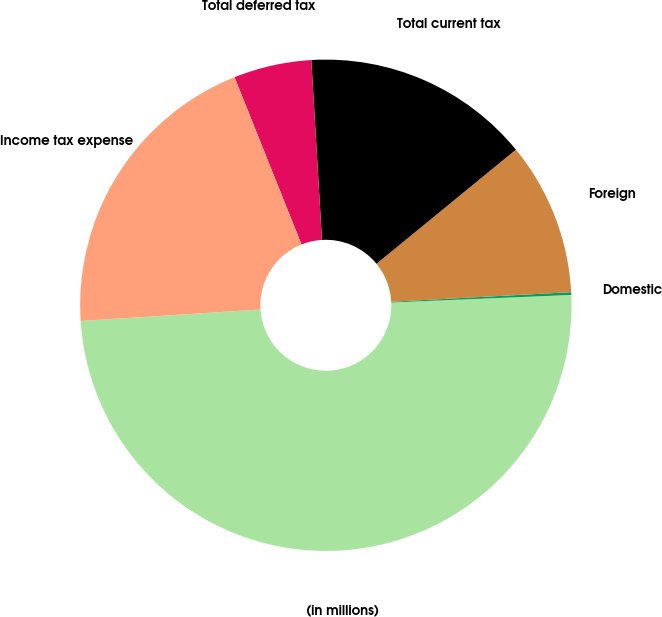Convert chart to OTSL. <chart><loc_0><loc_0><loc_500><loc_500><pie_chart><fcel>(in millions)<fcel>Domestic<fcel>Foreign<fcel>Total current tax<fcel>Total deferred tax<fcel>Income tax expense<nl><fcel>49.65%<fcel>0.18%<fcel>10.07%<fcel>15.02%<fcel>5.12%<fcel>19.96%<nl></chart> 